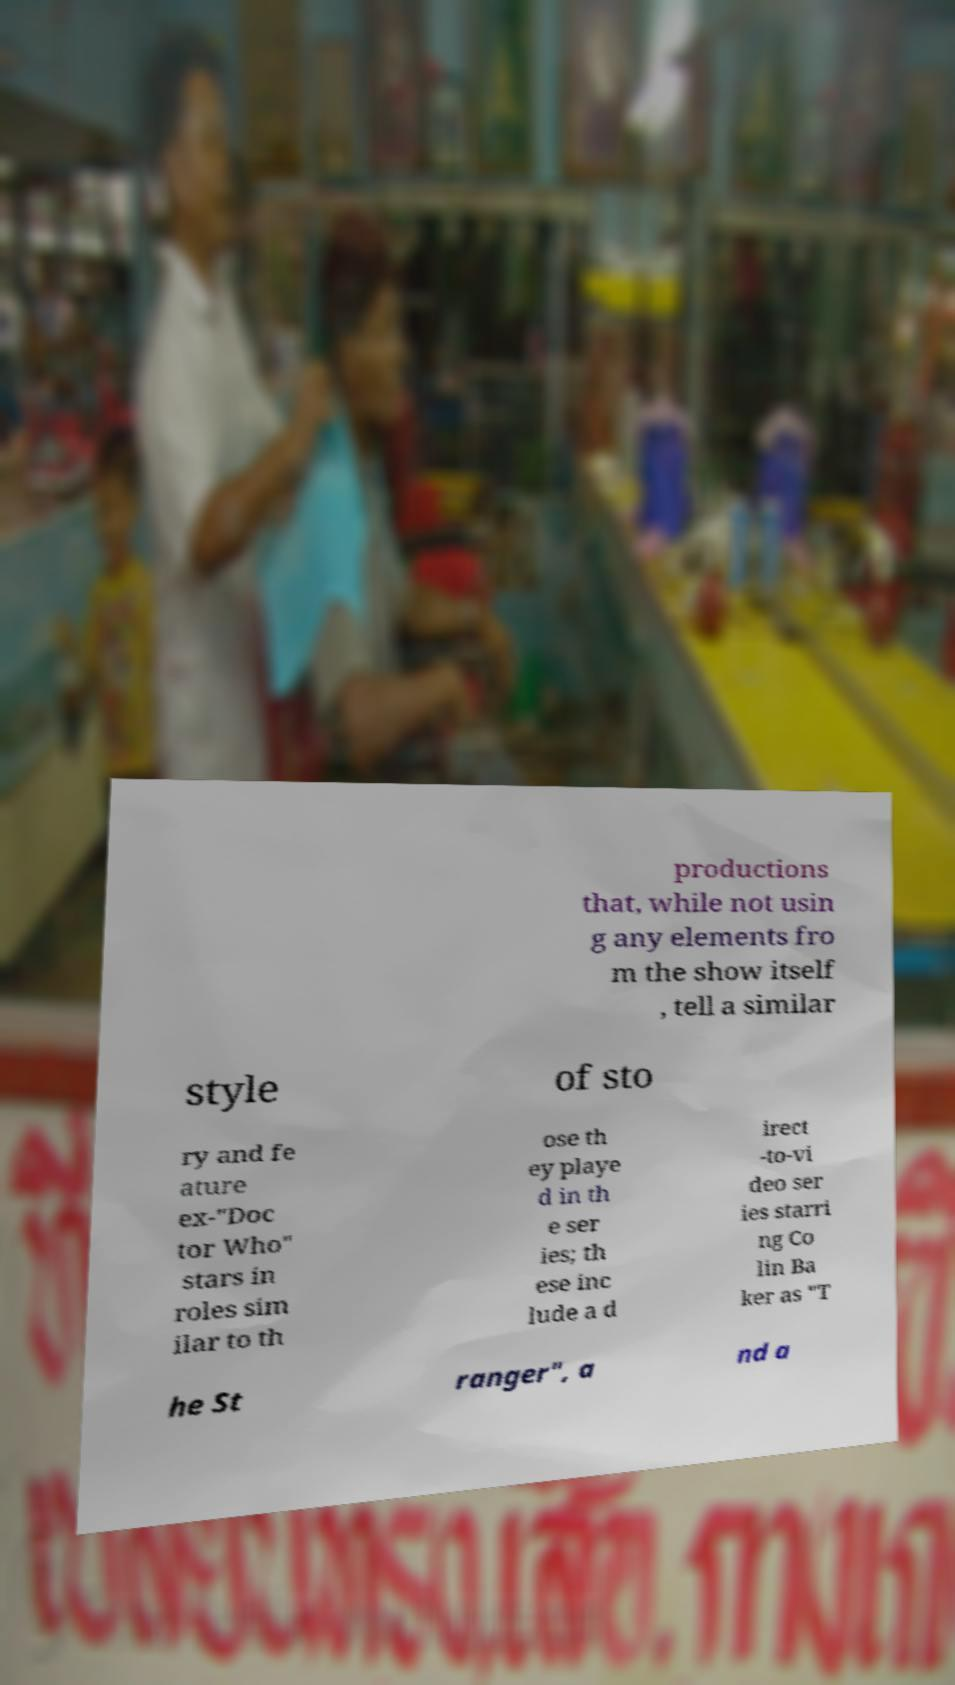Please identify and transcribe the text found in this image. productions that, while not usin g any elements fro m the show itself , tell a similar style of sto ry and fe ature ex-"Doc tor Who" stars in roles sim ilar to th ose th ey playe d in th e ser ies; th ese inc lude a d irect -to-vi deo ser ies starri ng Co lin Ba ker as "T he St ranger", a nd a 